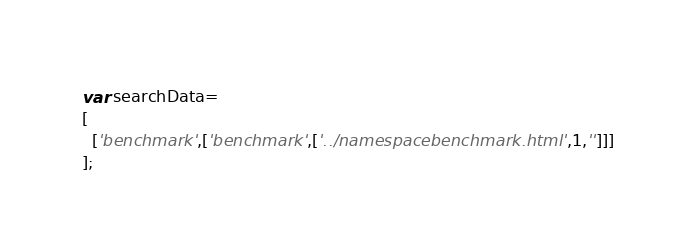<code> <loc_0><loc_0><loc_500><loc_500><_JavaScript_>var searchData=
[
  ['benchmark',['benchmark',['../namespacebenchmark.html',1,'']]]
];
</code> 